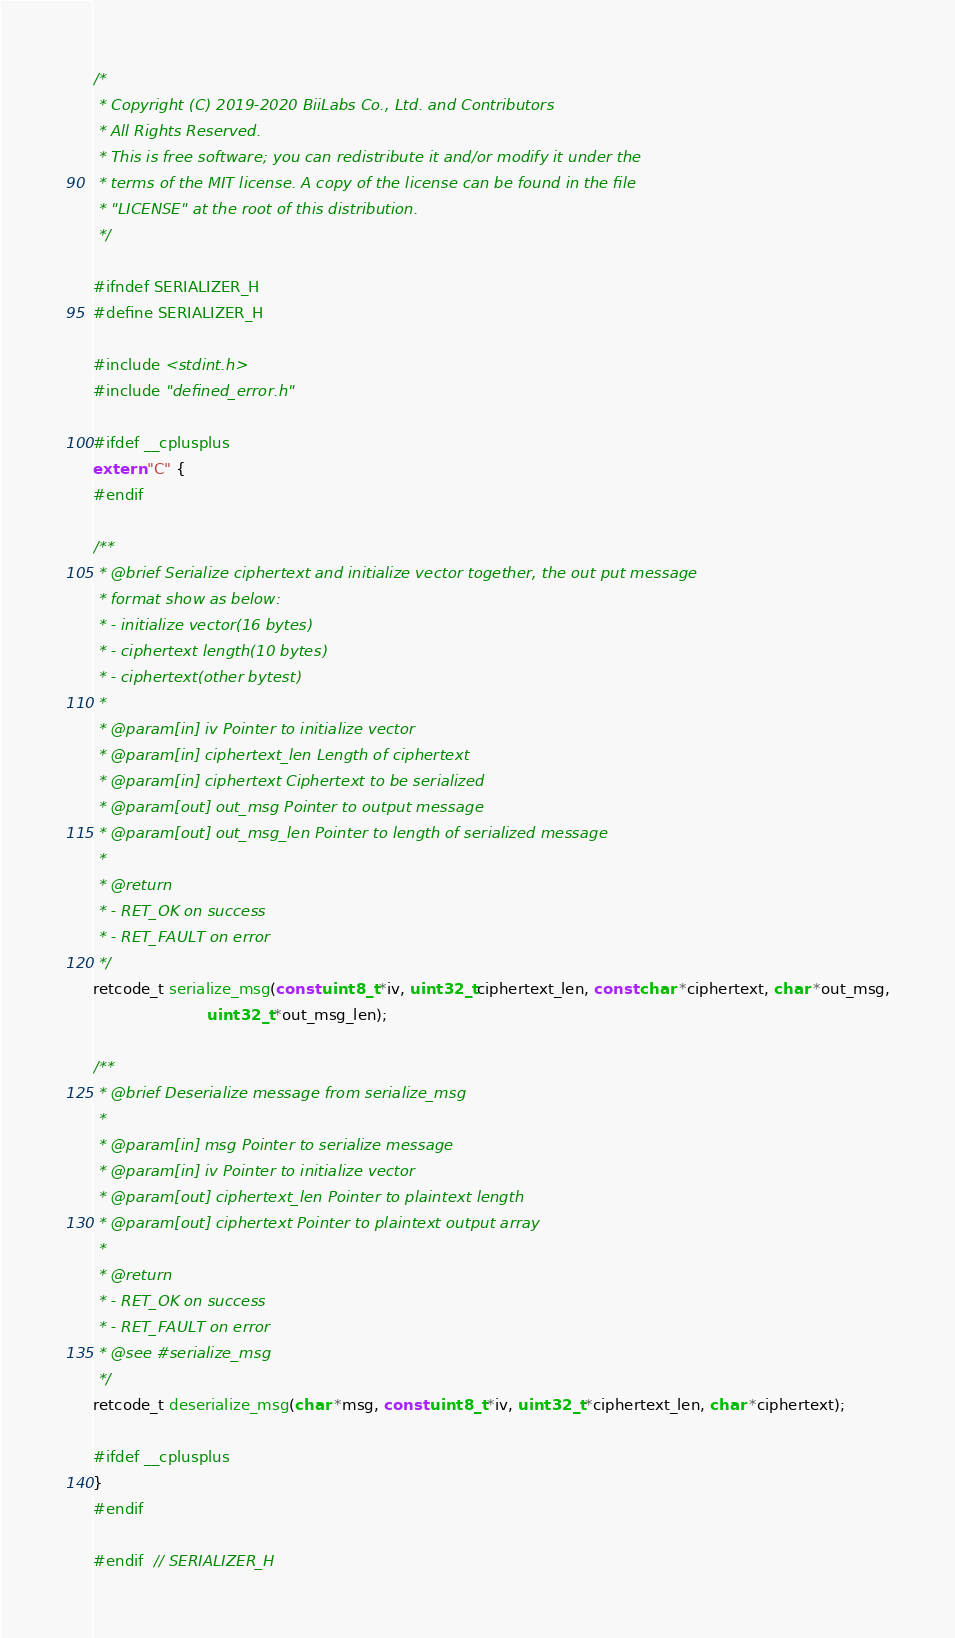Convert code to text. <code><loc_0><loc_0><loc_500><loc_500><_C_>/*
 * Copyright (C) 2019-2020 BiiLabs Co., Ltd. and Contributors
 * All Rights Reserved.
 * This is free software; you can redistribute it and/or modify it under the
 * terms of the MIT license. A copy of the license can be found in the file
 * "LICENSE" at the root of this distribution.
 */

#ifndef SERIALIZER_H
#define SERIALIZER_H

#include <stdint.h>
#include "defined_error.h"

#ifdef __cplusplus
extern "C" {
#endif

/**
 * @brief Serialize ciphertext and initialize vector together, the out put message
 * format show as below:
 * - initialize vector(16 bytes)
 * - ciphertext length(10 bytes)
 * - ciphertext(other bytest)
 *
 * @param[in] iv Pointer to initialize vector
 * @param[in] ciphertext_len Length of ciphertext
 * @param[in] ciphertext Ciphertext to be serialized
 * @param[out] out_msg Pointer to output message
 * @param[out] out_msg_len Pointer to length of serialized message
 *
 * @return
 * - RET_OK on success
 * - RET_FAULT on error
 */
retcode_t serialize_msg(const uint8_t *iv, uint32_t ciphertext_len, const char *ciphertext, char *out_msg,
                        uint32_t *out_msg_len);

/**
 * @brief Deserialize message from serialize_msg
 *
 * @param[in] msg Pointer to serialize message
 * @param[in] iv Pointer to initialize vector
 * @param[out] ciphertext_len Pointer to plaintext length
 * @param[out] ciphertext Pointer to plaintext output array
 *
 * @return
 * - RET_OK on success
 * - RET_FAULT on error
 * @see #serialize_msg
 */
retcode_t deserialize_msg(char *msg, const uint8_t *iv, uint32_t *ciphertext_len, char *ciphertext);

#ifdef __cplusplus
}
#endif

#endif  // SERIALIZER_H
</code> 